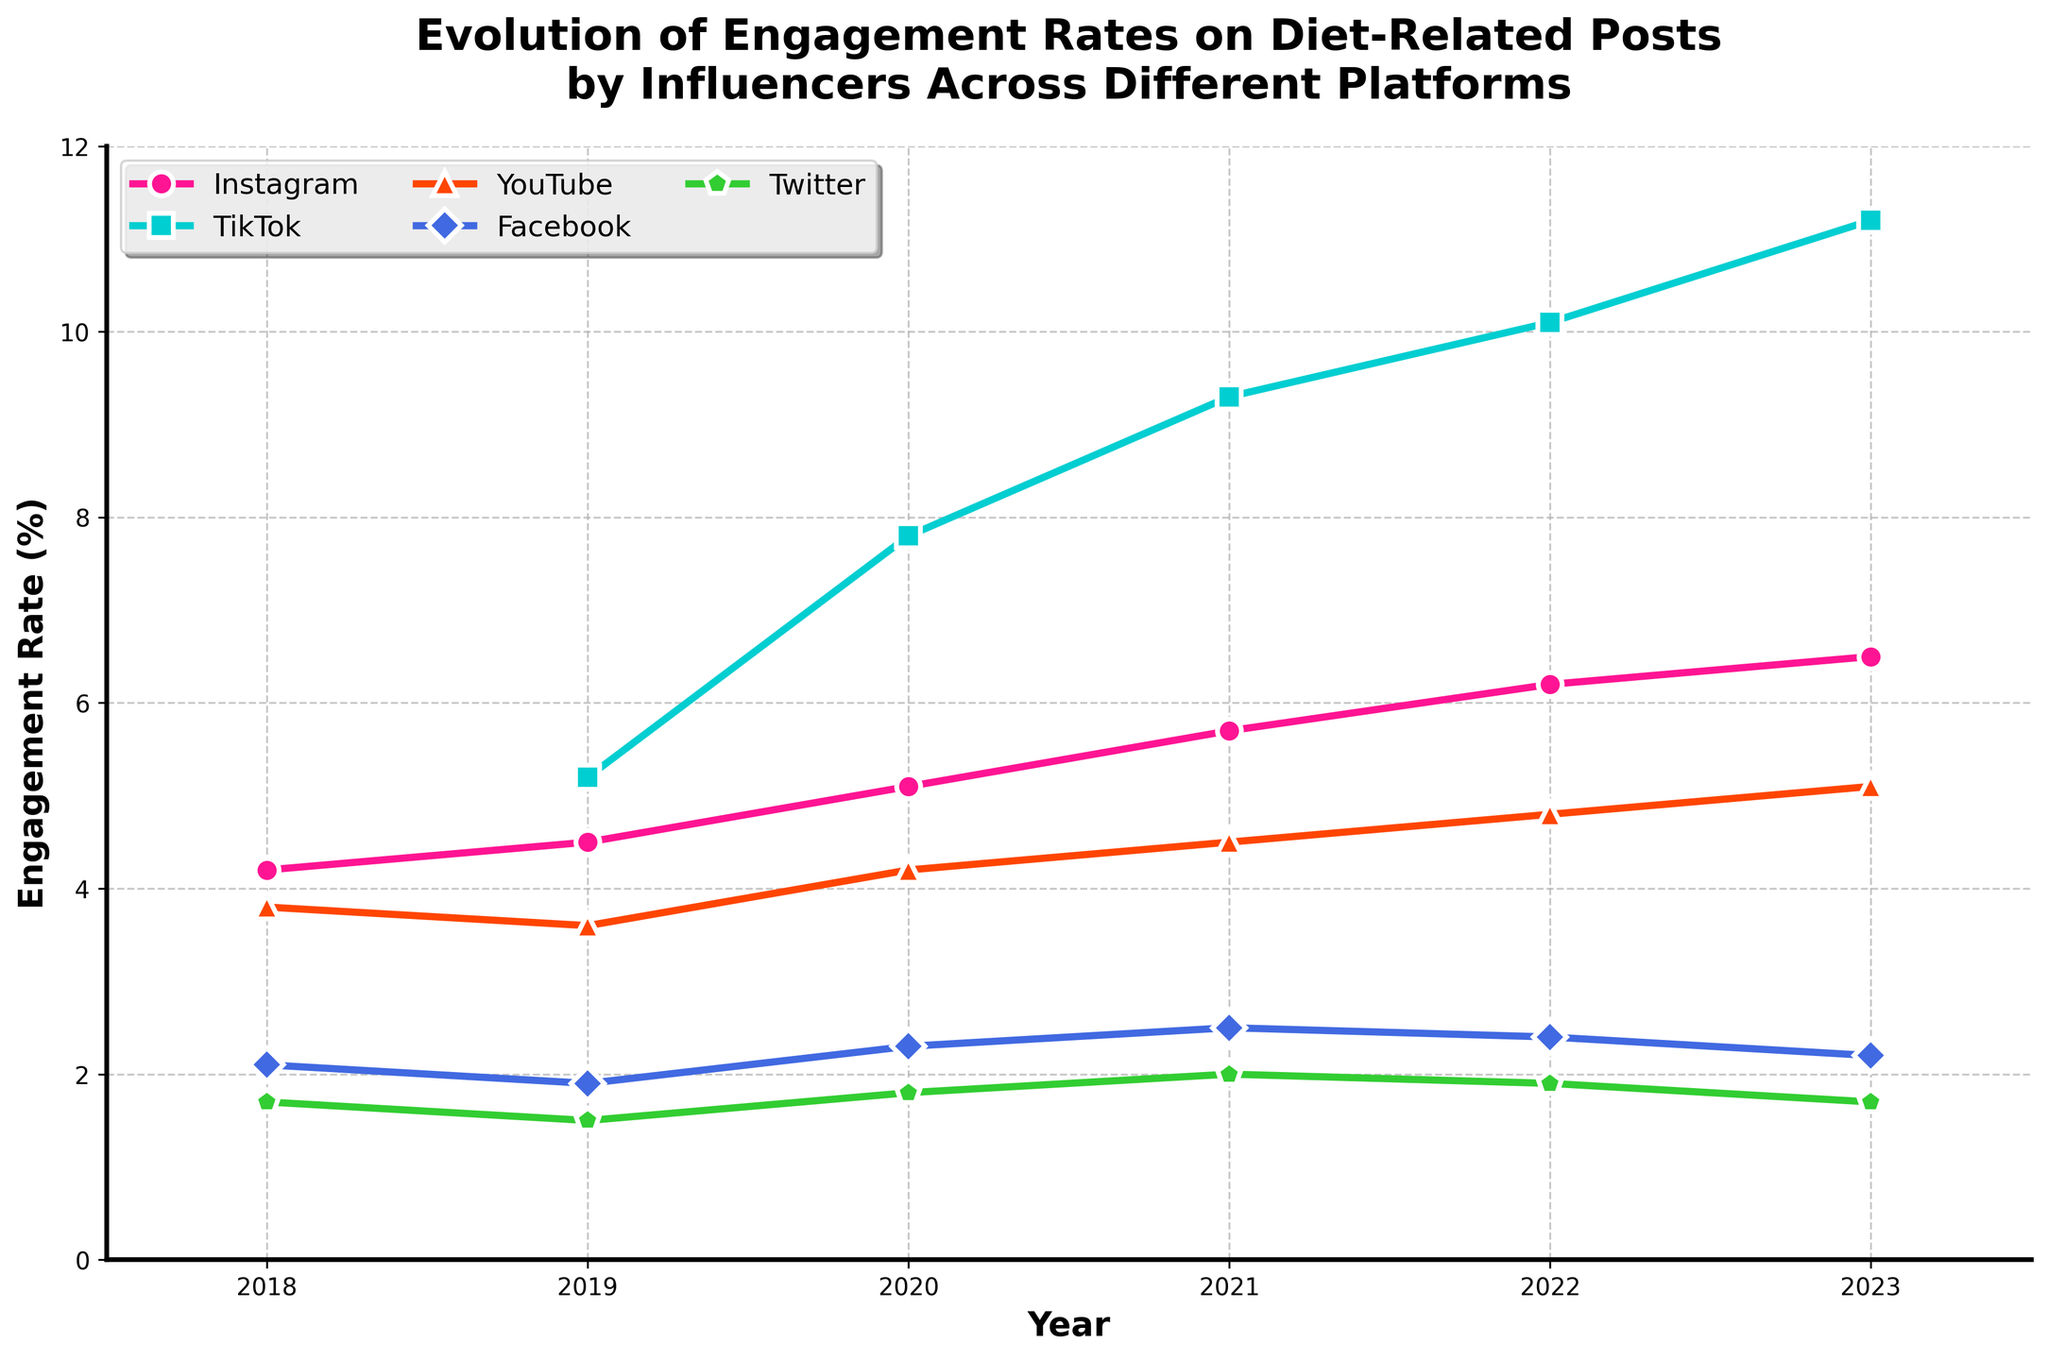What is the trend of engagement rates on Instagram between 2018 and 2023? From the line chart, observe the points plotted for Instagram from 2018 to 2023. They show an upward trend, starting at 4.2% in 2018 and peaking at 6.5% in 2023.
Answer: Upward trend In 2023, which platform had the highest engagement rate for diet-related posts? Look at the points plotted for the year 2023. TikTok shows the highest engagement rate at 11.2%.
Answer: TikTok Which platform saw its engagement rate decrease from 2020 to 2021? Check the trends between 2020 and 2021 for each platform. Only YouTube shows a decrease, from 4.2% to 4.5%.
Answer: YouTube What is the average engagement rate on TikTok over the period it is displayed? Add the engagement rates for TikTok (5.2%, 7.8%, 9.3%, 10.1%, and 11.2%). The sum is 43.6%. Divide by 5 (the number of years displayed).
Answer: 8.72% Which platform had the most stable engagement rate over the years shown? Examine the lines; Twitter appears flat and stable, with rates from 1.7% to 2.0%.
Answer: Twitter Which year did Instagram surpass a 5% engagement rate? Follow the Instagram line and notice it surpasses 5% between 2020 (5.1%) and 2021 (5.7%).
Answer: 2020 By how much did the engagement rate on Facebook change from 2018 to 2023? Check the values for Facebook in 2018 (2.1%) and 2023 (2.2%), then subtract the 2018 value from the 2023 value: 2.2% - 2.1% = 0.1%.
Answer: 0.1% Which platform's engagement rate saw the largest percentage increase from 2019 to 2023? Calculate the percentage increase for each platform over the years. For TikTok, it's (11.2% - 5.2%) / 5.2% = 115.4%. Repeat for others. TikTok has the largest percent change.
Answer: TikTok How did YouTube's engagement rate in 2023 compare to its rate in 2018? Compare YouTube's rates for 2018 (3.8%) and 2023 (5.1%). It increased by 5.1% - 3.8% = 1.3%.
Answer: Increased by 1.3% When did TikTok engagement rates first reach double digits? Find the year when TikTok surpasses 10%. It happens between 2021 (9.3%) and 2022 (10.1%).
Answer: 2022 